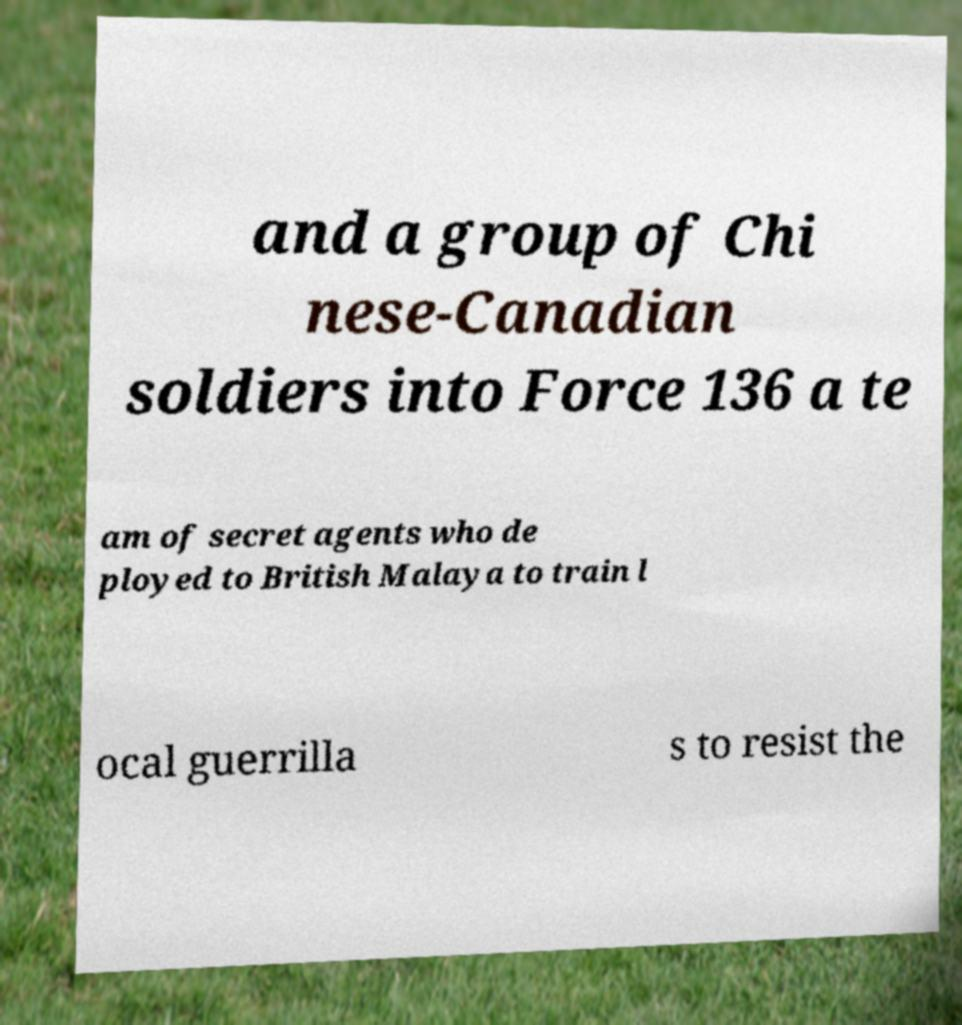Can you read and provide the text displayed in the image?This photo seems to have some interesting text. Can you extract and type it out for me? and a group of Chi nese-Canadian soldiers into Force 136 a te am of secret agents who de ployed to British Malaya to train l ocal guerrilla s to resist the 